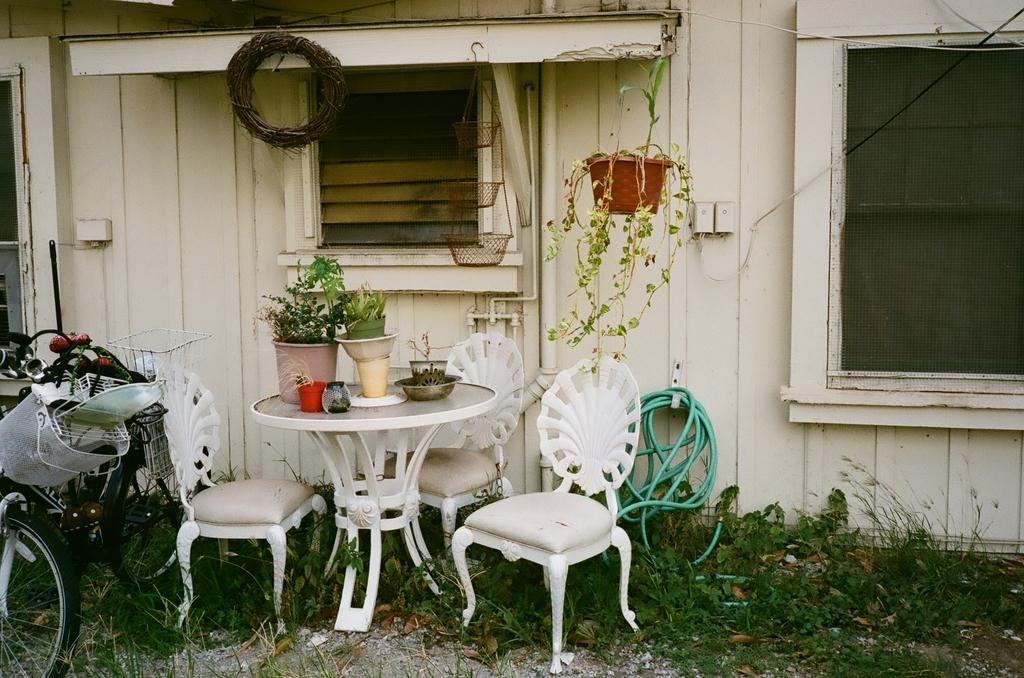What is placed on the table in the image? There are plants on the table in the image. How many chairs are visible in the image? There are three chairs in the image. What type of object can be seen near the ceiling in the image? A plant hanging in the image. What is the purpose of the water pipe in the image? The water pipe is visible in the image, but its purpose cannot be determined from the image alone. What mode of transportation is present in the image? A bicycle is present in the image. What level of experience does the person using the rake have in the image? There is no rake present in the image, so it is impossible to determine the experience level of anyone using it. How does the anger in the image manifest itself? There is no indication of anger in the image, so it cannot be determined how it might manifest itself. 